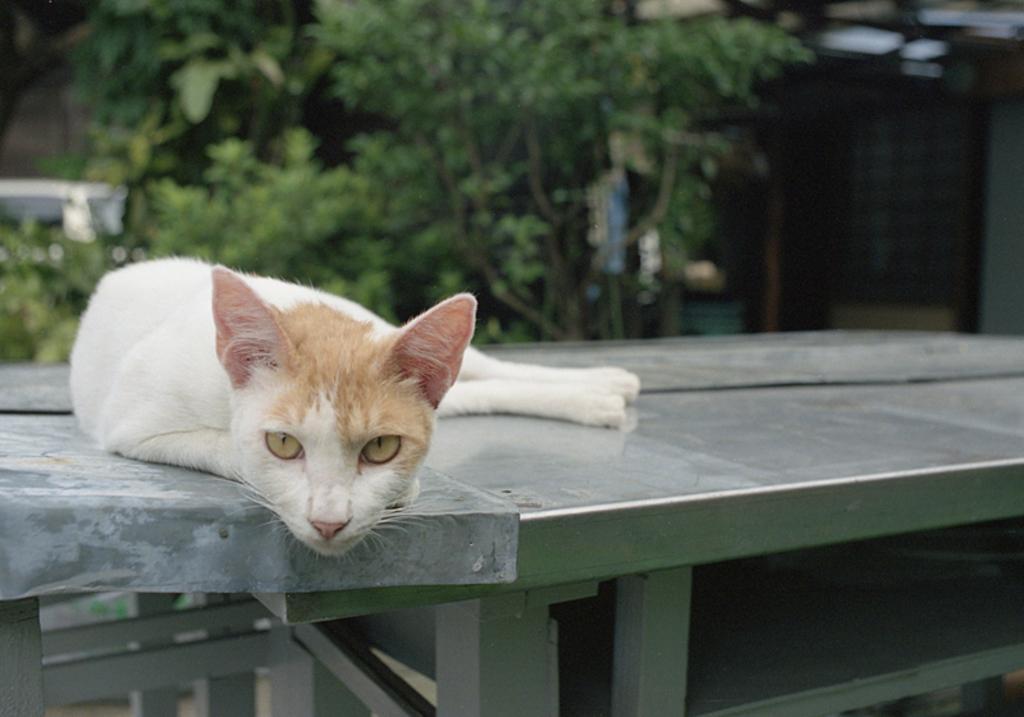Could you give a brief overview of what you see in this image? In this image there is a cat laying on the bench. In the background there are trees. 